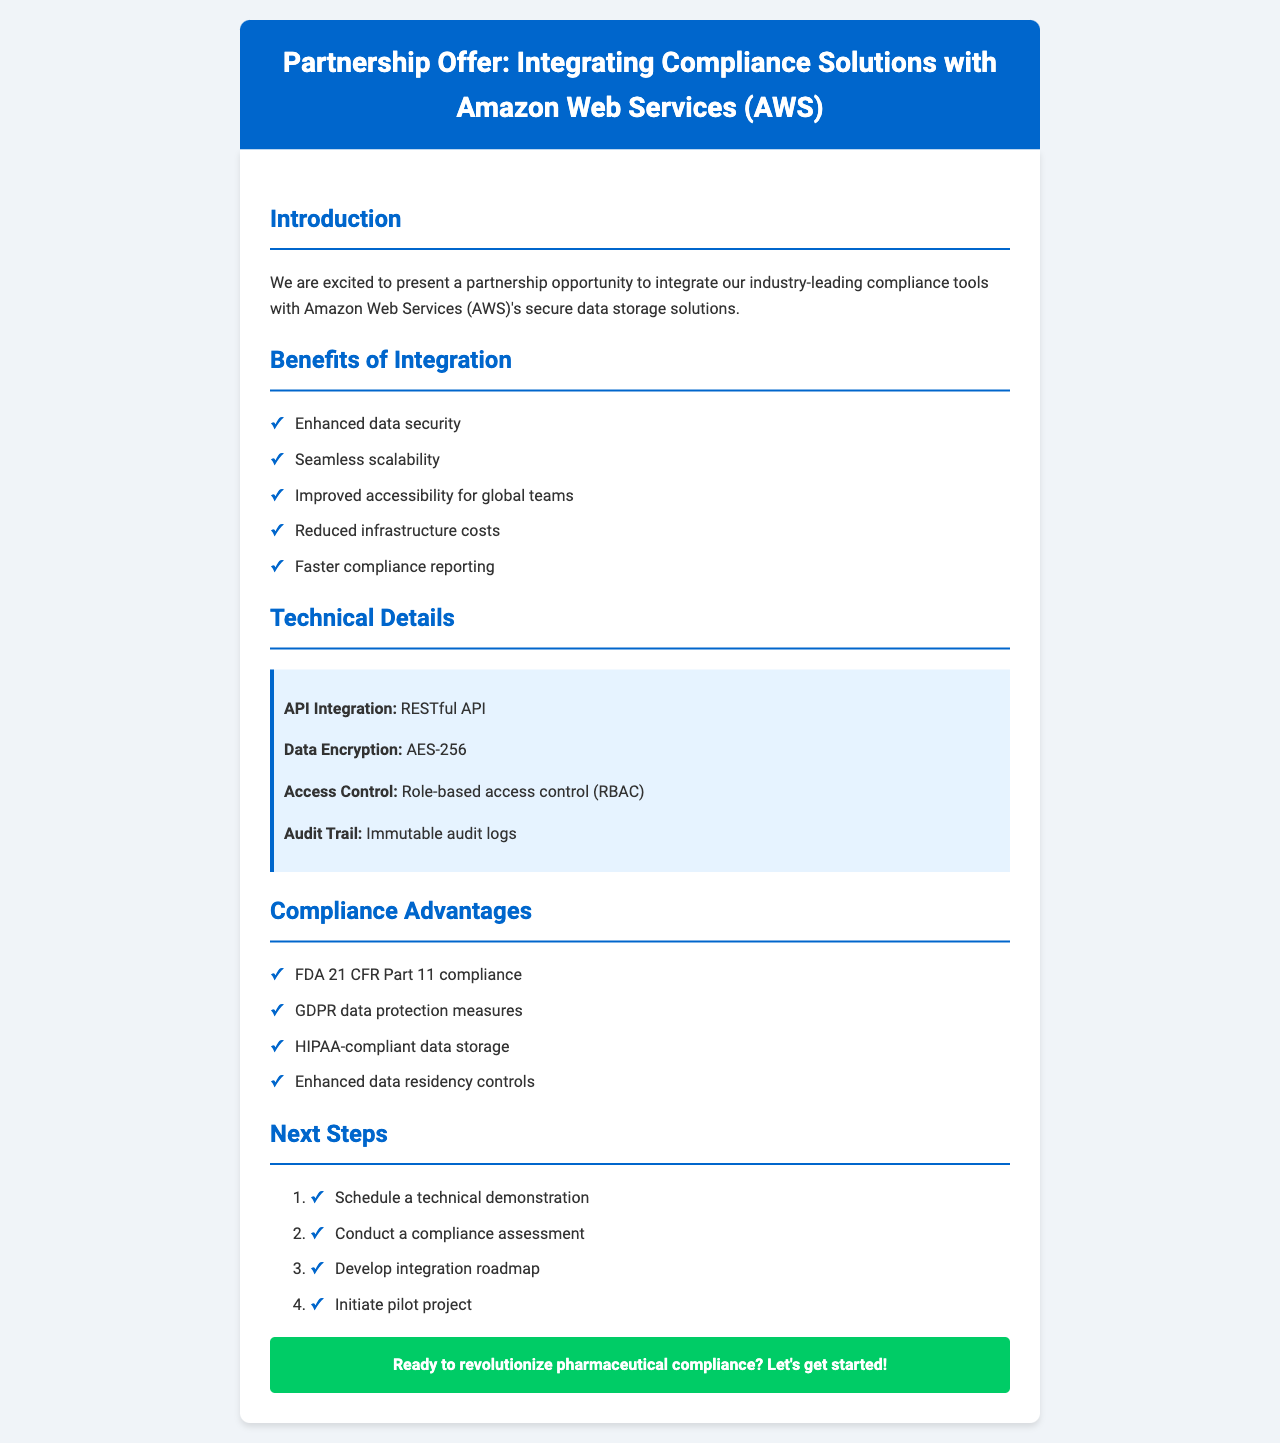What is the name of the cloud service provider? The name of the cloud service provider is mentioned at the beginning of the letter.
Answer: Amazon Web Services (AWS) What compliance tool is mentioned first? The first compliance tool listed under the compliance tools section is detailed in the document.
Answer: PharmaSafe Tracker How many integration benefits are listed? The number of benefits mentioned in the integration section can be counted from the list provided.
Answer: Five What type of API is used for integration? The API type utilized for integration is specified in the technical details section.
Answer: RESTful API Which regulatory body is mentioned as the first in the compliance advantages? The first regulatory body listed among the compliance advantages is stated in the document.
Answer: FDA (Food and Drug Administration) What is the encryption standard used in this integration? The document specifies the encryption standard used in the technical details section.
Answer: AES-256 What is one of the next steps listed for the partnership? A specific step outlined as part of the next steps can be found in that section of the letter.
Answer: Schedule a technical demonstration How many potential clients are mentioned? The number of potential clients can be counted from the list provided in the document.
Answer: Four 